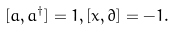<formula> <loc_0><loc_0><loc_500><loc_500>[ a , a ^ { \dagger } ] = 1 , [ x , \partial ] = - 1 .</formula> 